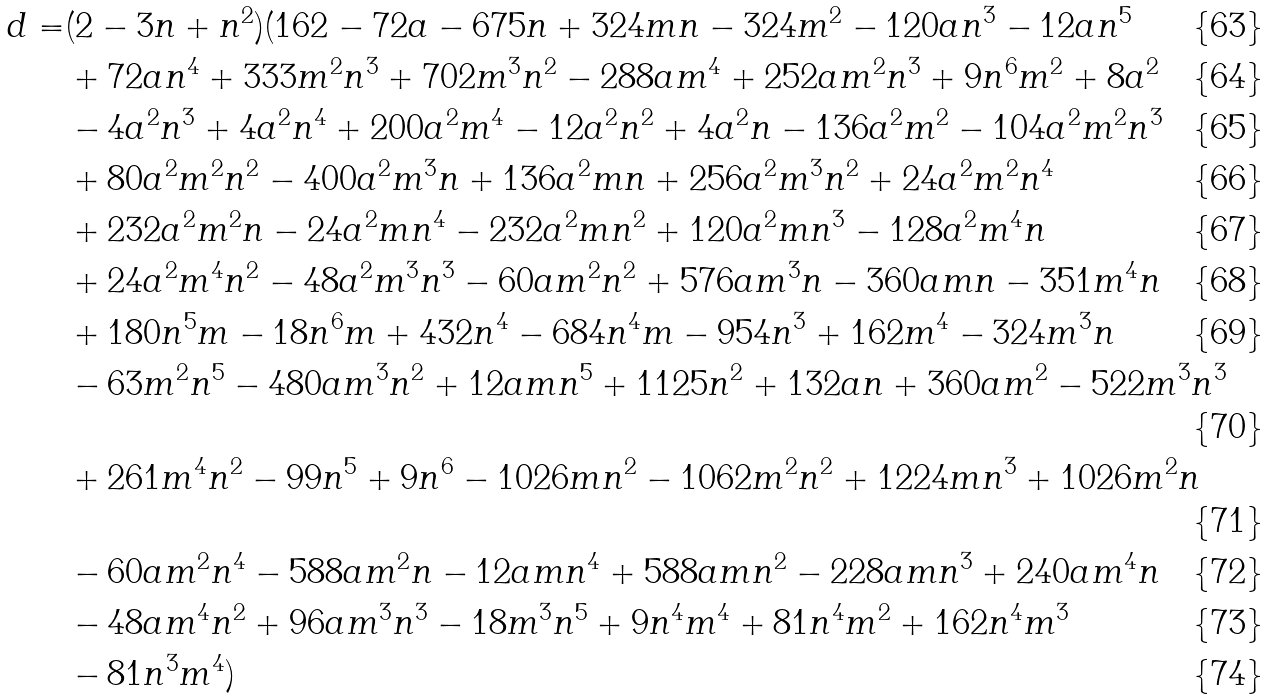Convert formula to latex. <formula><loc_0><loc_0><loc_500><loc_500>d = & ( 2 - 3 n + n ^ { 2 } ) ( 1 6 2 - 7 2 a - 6 7 5 n + 3 2 4 m n - 3 2 4 m ^ { 2 } - 1 2 0 a n ^ { 3 } - 1 2 a n ^ { 5 } \\ & + 7 2 a n ^ { 4 } + 3 3 3 m ^ { 2 } n ^ { 3 } + 7 0 2 m ^ { 3 } n ^ { 2 } - 2 8 8 a m ^ { 4 } + 2 5 2 a m ^ { 2 } n ^ { 3 } + 9 n ^ { 6 } m ^ { 2 } + 8 a ^ { 2 } \\ & - 4 a ^ { 2 } n ^ { 3 } + 4 a ^ { 2 } n ^ { 4 } + 2 0 0 a ^ { 2 } m ^ { 4 } - 1 2 a ^ { 2 } n ^ { 2 } + 4 a ^ { 2 } n - 1 3 6 a ^ { 2 } m ^ { 2 } - 1 0 4 a ^ { 2 } m ^ { 2 } n ^ { 3 } \\ & + 8 0 a ^ { 2 } m ^ { 2 } n ^ { 2 } - 4 0 0 a ^ { 2 } m ^ { 3 } n + 1 3 6 a ^ { 2 } m n + 2 5 6 a ^ { 2 } m ^ { 3 } n ^ { 2 } + 2 4 a ^ { 2 } m ^ { 2 } n ^ { 4 } \\ & + 2 3 2 a ^ { 2 } m ^ { 2 } n - 2 4 a ^ { 2 } m n ^ { 4 } - 2 3 2 a ^ { 2 } m n ^ { 2 } + 1 2 0 a ^ { 2 } m n ^ { 3 } - 1 2 8 a ^ { 2 } m ^ { 4 } n \\ & + 2 4 a ^ { 2 } m ^ { 4 } n ^ { 2 } - 4 8 a ^ { 2 } m ^ { 3 } n ^ { 3 } - 6 0 a m ^ { 2 } n ^ { 2 } + 5 7 6 a m ^ { 3 } n - 3 6 0 a m n - 3 5 1 m ^ { 4 } n \\ & + 1 8 0 n ^ { 5 } m - 1 8 n ^ { 6 } m + 4 3 2 n ^ { 4 } - 6 8 4 n ^ { 4 } m - 9 5 4 n ^ { 3 } + 1 6 2 m ^ { 4 } - 3 2 4 m ^ { 3 } n \\ & - 6 3 m ^ { 2 } n ^ { 5 } - 4 8 0 a m ^ { 3 } n ^ { 2 } + 1 2 a m n ^ { 5 } + 1 1 2 5 n ^ { 2 } + 1 3 2 a n + 3 6 0 a m ^ { 2 } - 5 2 2 m ^ { 3 } n ^ { 3 } \\ & + 2 6 1 m ^ { 4 } n ^ { 2 } - 9 9 n ^ { 5 } + 9 n ^ { 6 } - 1 0 2 6 m n ^ { 2 } - 1 0 6 2 m ^ { 2 } n ^ { 2 } + 1 2 2 4 m n ^ { 3 } + 1 0 2 6 m ^ { 2 } n \\ & - 6 0 a m ^ { 2 } n ^ { 4 } - 5 8 8 a m ^ { 2 } n - 1 2 a m n ^ { 4 } + 5 8 8 a m n ^ { 2 } - 2 2 8 a m n ^ { 3 } + 2 4 0 a m ^ { 4 } n \\ & - 4 8 a m ^ { 4 } n ^ { 2 } + 9 6 a m ^ { 3 } n ^ { 3 } - 1 8 m ^ { 3 } n ^ { 5 } + 9 n ^ { 4 } m ^ { 4 } + 8 1 n ^ { 4 } m ^ { 2 } + 1 6 2 n ^ { 4 } m ^ { 3 } \\ & - 8 1 n ^ { 3 } m ^ { 4 } )</formula> 